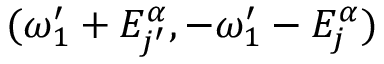Convert formula to latex. <formula><loc_0><loc_0><loc_500><loc_500>( \omega _ { 1 } ^ { \prime } + E _ { j ^ { \prime } } ^ { \alpha } , - \omega _ { 1 } ^ { \prime } - E _ { j } ^ { \alpha } )</formula> 